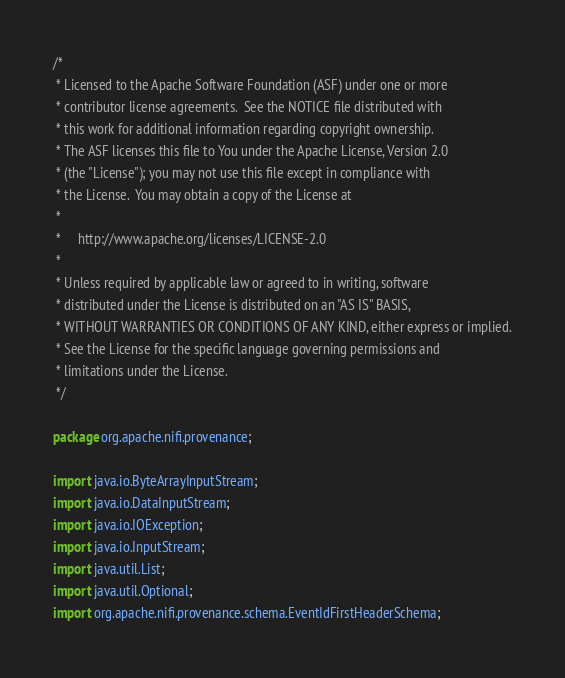<code> <loc_0><loc_0><loc_500><loc_500><_Java_>/*
 * Licensed to the Apache Software Foundation (ASF) under one or more
 * contributor license agreements.  See the NOTICE file distributed with
 * this work for additional information regarding copyright ownership.
 * The ASF licenses this file to You under the Apache License, Version 2.0
 * (the "License"); you may not use this file except in compliance with
 * the License.  You may obtain a copy of the License at
 *
 *     http://www.apache.org/licenses/LICENSE-2.0
 *
 * Unless required by applicable law or agreed to in writing, software
 * distributed under the License is distributed on an "AS IS" BASIS,
 * WITHOUT WARRANTIES OR CONDITIONS OF ANY KIND, either express or implied.
 * See the License for the specific language governing permissions and
 * limitations under the License.
 */

package org.apache.nifi.provenance;

import java.io.ByteArrayInputStream;
import java.io.DataInputStream;
import java.io.IOException;
import java.io.InputStream;
import java.util.List;
import java.util.Optional;
import org.apache.nifi.provenance.schema.EventIdFirstHeaderSchema;</code> 